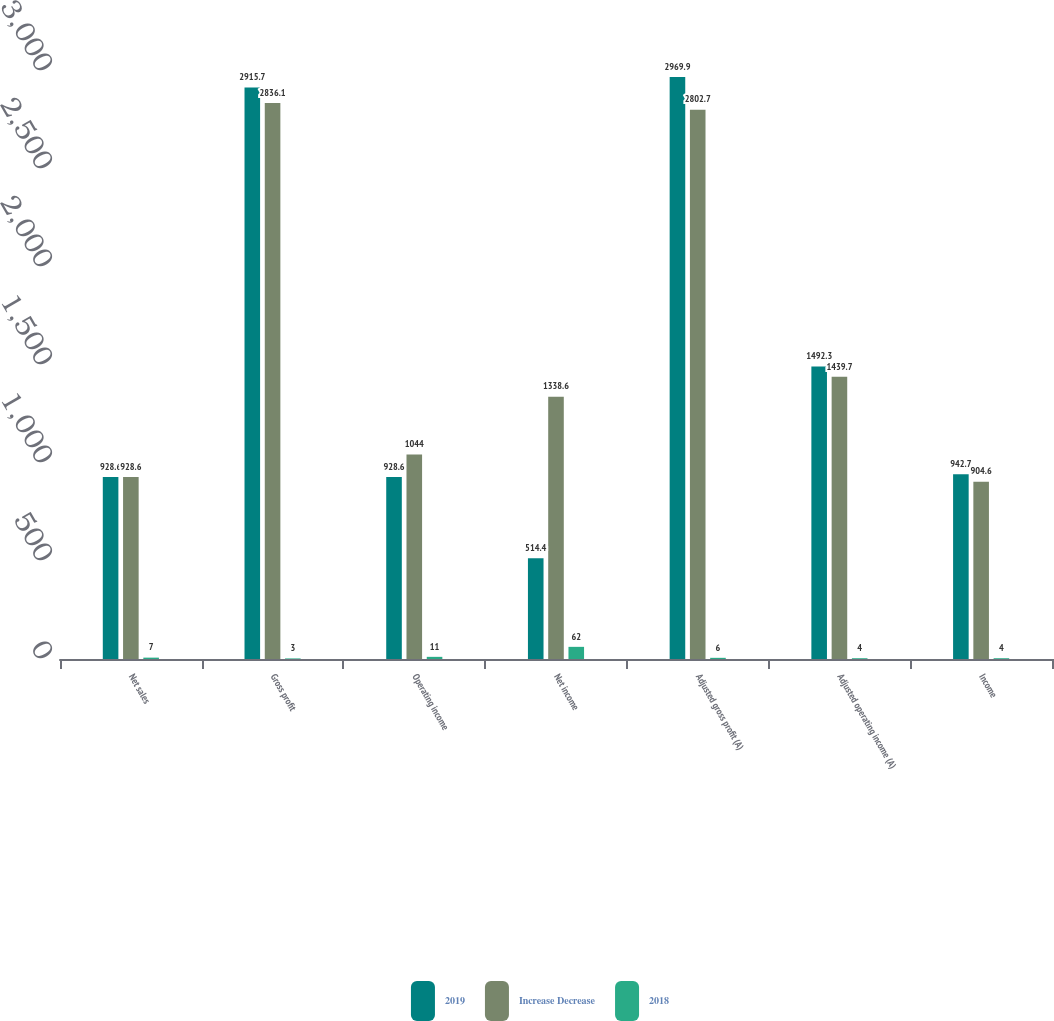Convert chart. <chart><loc_0><loc_0><loc_500><loc_500><stacked_bar_chart><ecel><fcel>Net sales<fcel>Gross profit<fcel>Operating income<fcel>Net income<fcel>Adjusted gross profit (A)<fcel>Adjusted operating income (A)<fcel>Income<nl><fcel>2019<fcel>928.6<fcel>2915.7<fcel>928.6<fcel>514.4<fcel>2969.9<fcel>1492.3<fcel>942.7<nl><fcel>Increase Decrease<fcel>928.6<fcel>2836.1<fcel>1044<fcel>1338.6<fcel>2802.7<fcel>1439.7<fcel>904.6<nl><fcel>2018<fcel>7<fcel>3<fcel>11<fcel>62<fcel>6<fcel>4<fcel>4<nl></chart> 